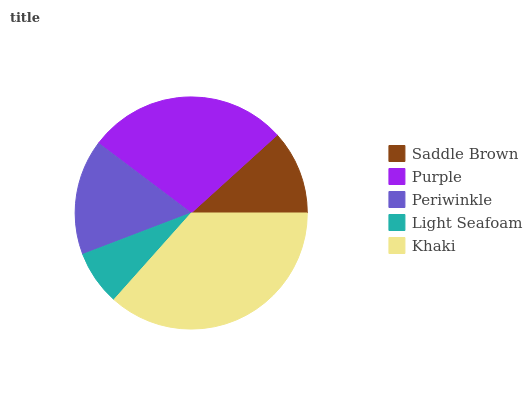Is Light Seafoam the minimum?
Answer yes or no. Yes. Is Khaki the maximum?
Answer yes or no. Yes. Is Purple the minimum?
Answer yes or no. No. Is Purple the maximum?
Answer yes or no. No. Is Purple greater than Saddle Brown?
Answer yes or no. Yes. Is Saddle Brown less than Purple?
Answer yes or no. Yes. Is Saddle Brown greater than Purple?
Answer yes or no. No. Is Purple less than Saddle Brown?
Answer yes or no. No. Is Periwinkle the high median?
Answer yes or no. Yes. Is Periwinkle the low median?
Answer yes or no. Yes. Is Light Seafoam the high median?
Answer yes or no. No. Is Saddle Brown the low median?
Answer yes or no. No. 